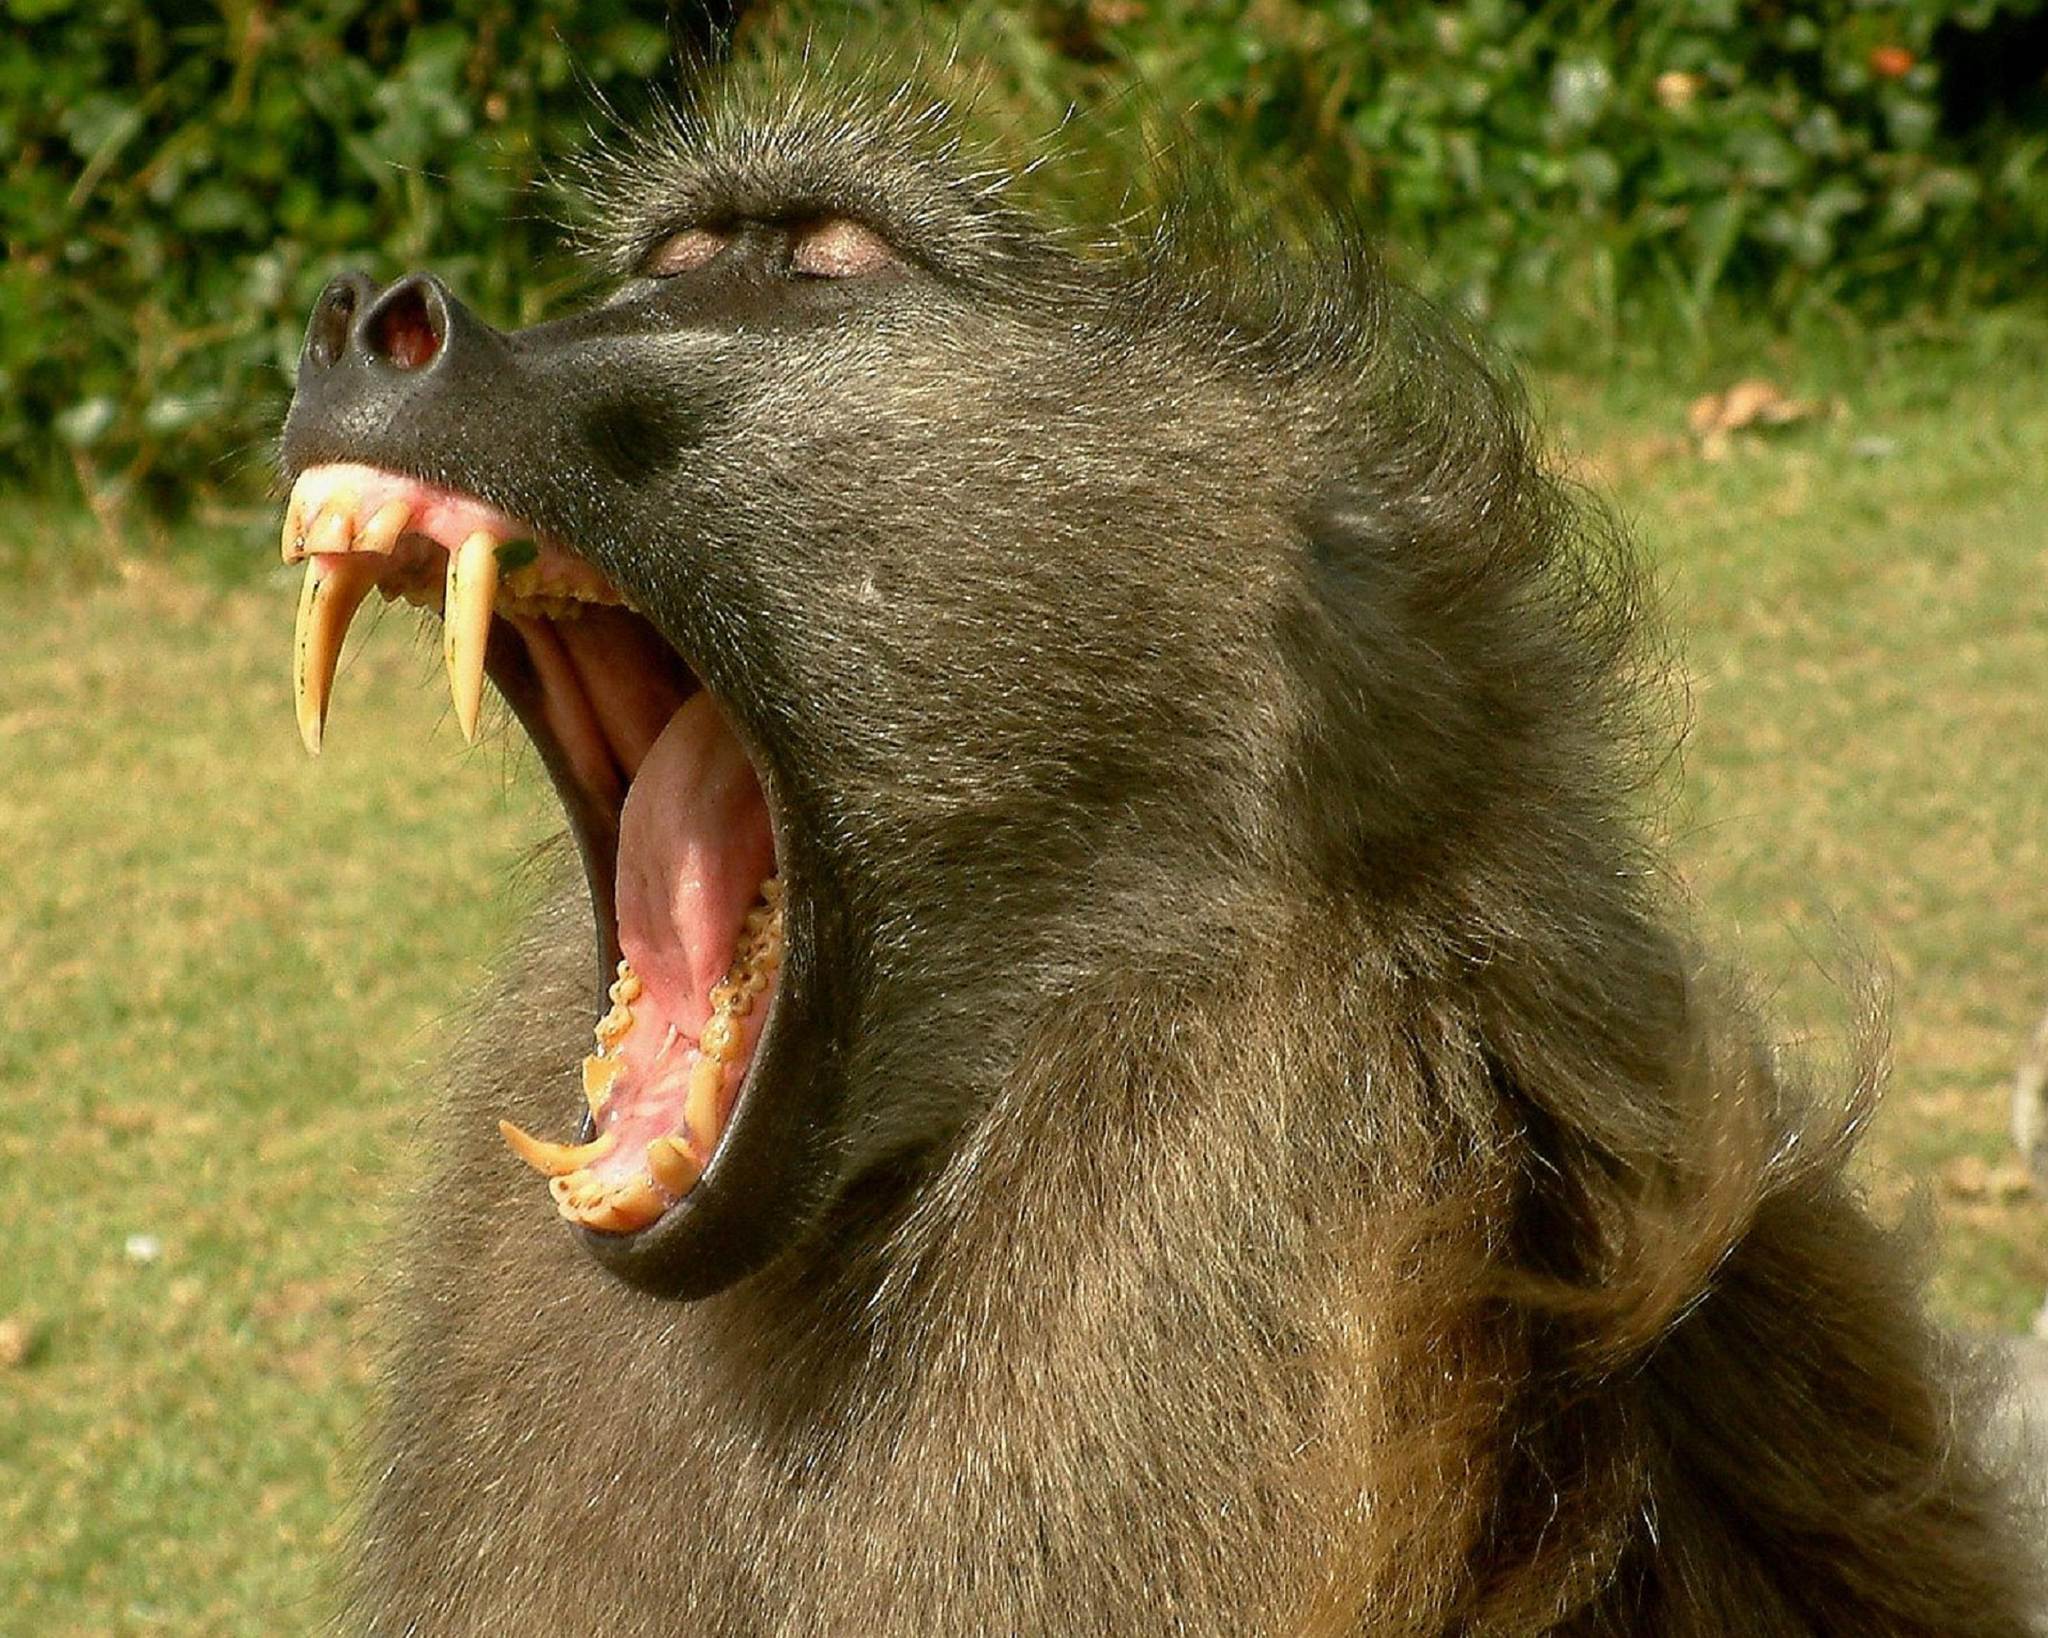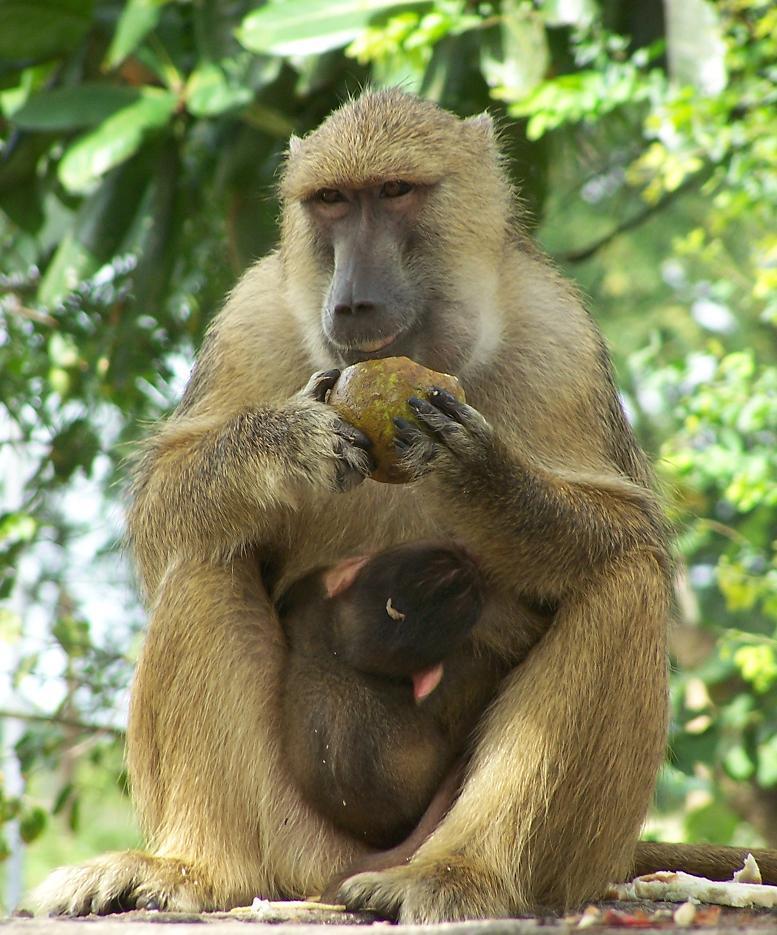The first image is the image on the left, the second image is the image on the right. Considering the images on both sides, is "One image shows the face of a fang-baring baboon in profile, and the other image includes a baby baboon." valid? Answer yes or no. Yes. 